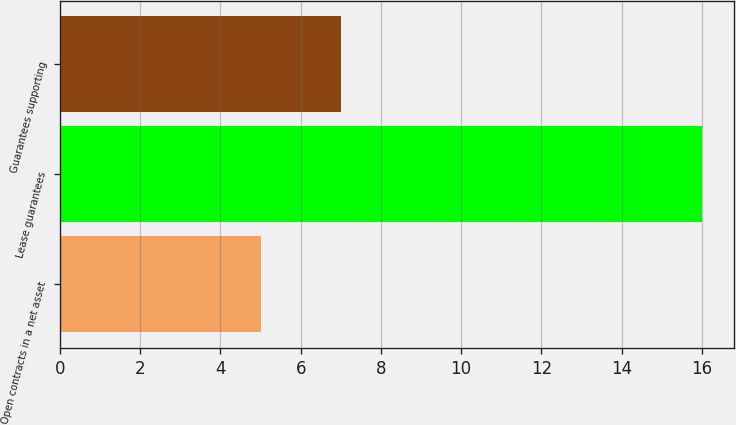Convert chart to OTSL. <chart><loc_0><loc_0><loc_500><loc_500><bar_chart><fcel>Open contracts in a net asset<fcel>Lease guarantees<fcel>Guarantees supporting<nl><fcel>5<fcel>16<fcel>7<nl></chart> 